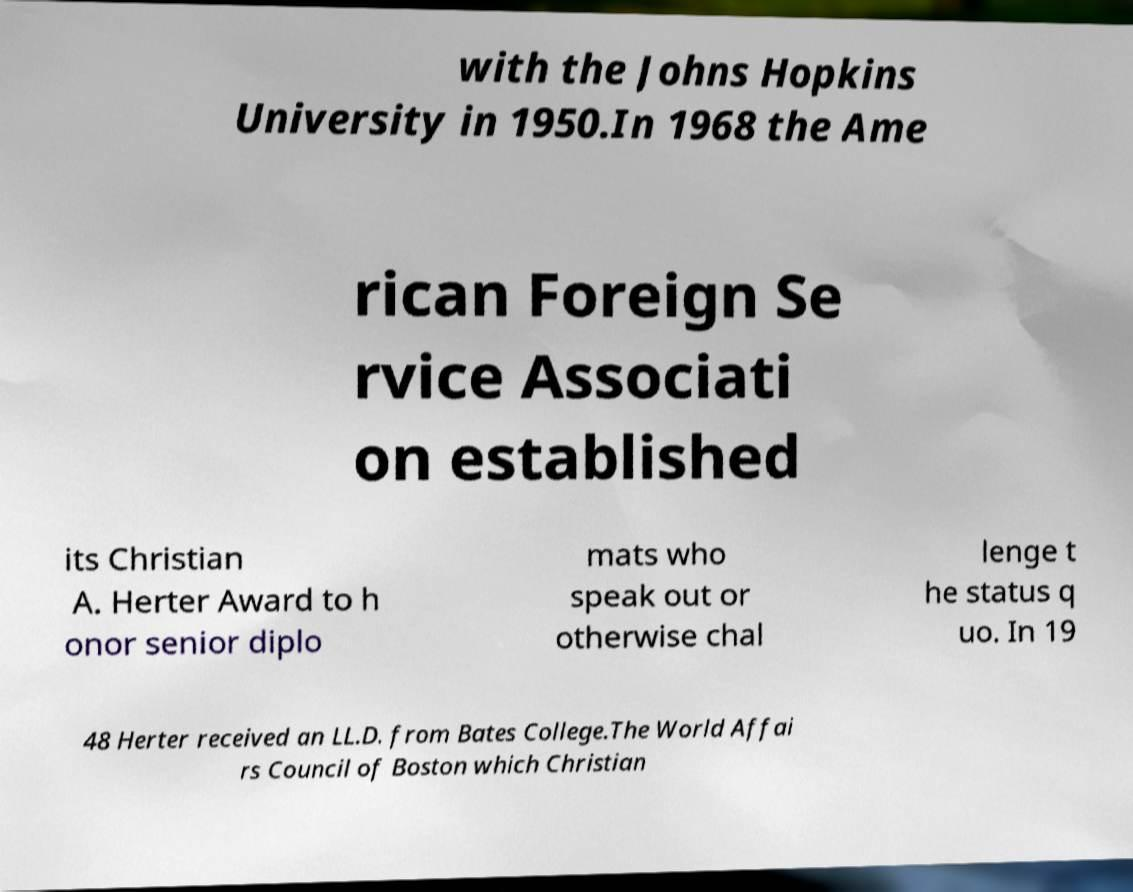Can you accurately transcribe the text from the provided image for me? with the Johns Hopkins University in 1950.In 1968 the Ame rican Foreign Se rvice Associati on established its Christian A. Herter Award to h onor senior diplo mats who speak out or otherwise chal lenge t he status q uo. In 19 48 Herter received an LL.D. from Bates College.The World Affai rs Council of Boston which Christian 